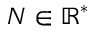<formula> <loc_0><loc_0><loc_500><loc_500>N \in \mathbb { R } ^ { * }</formula> 